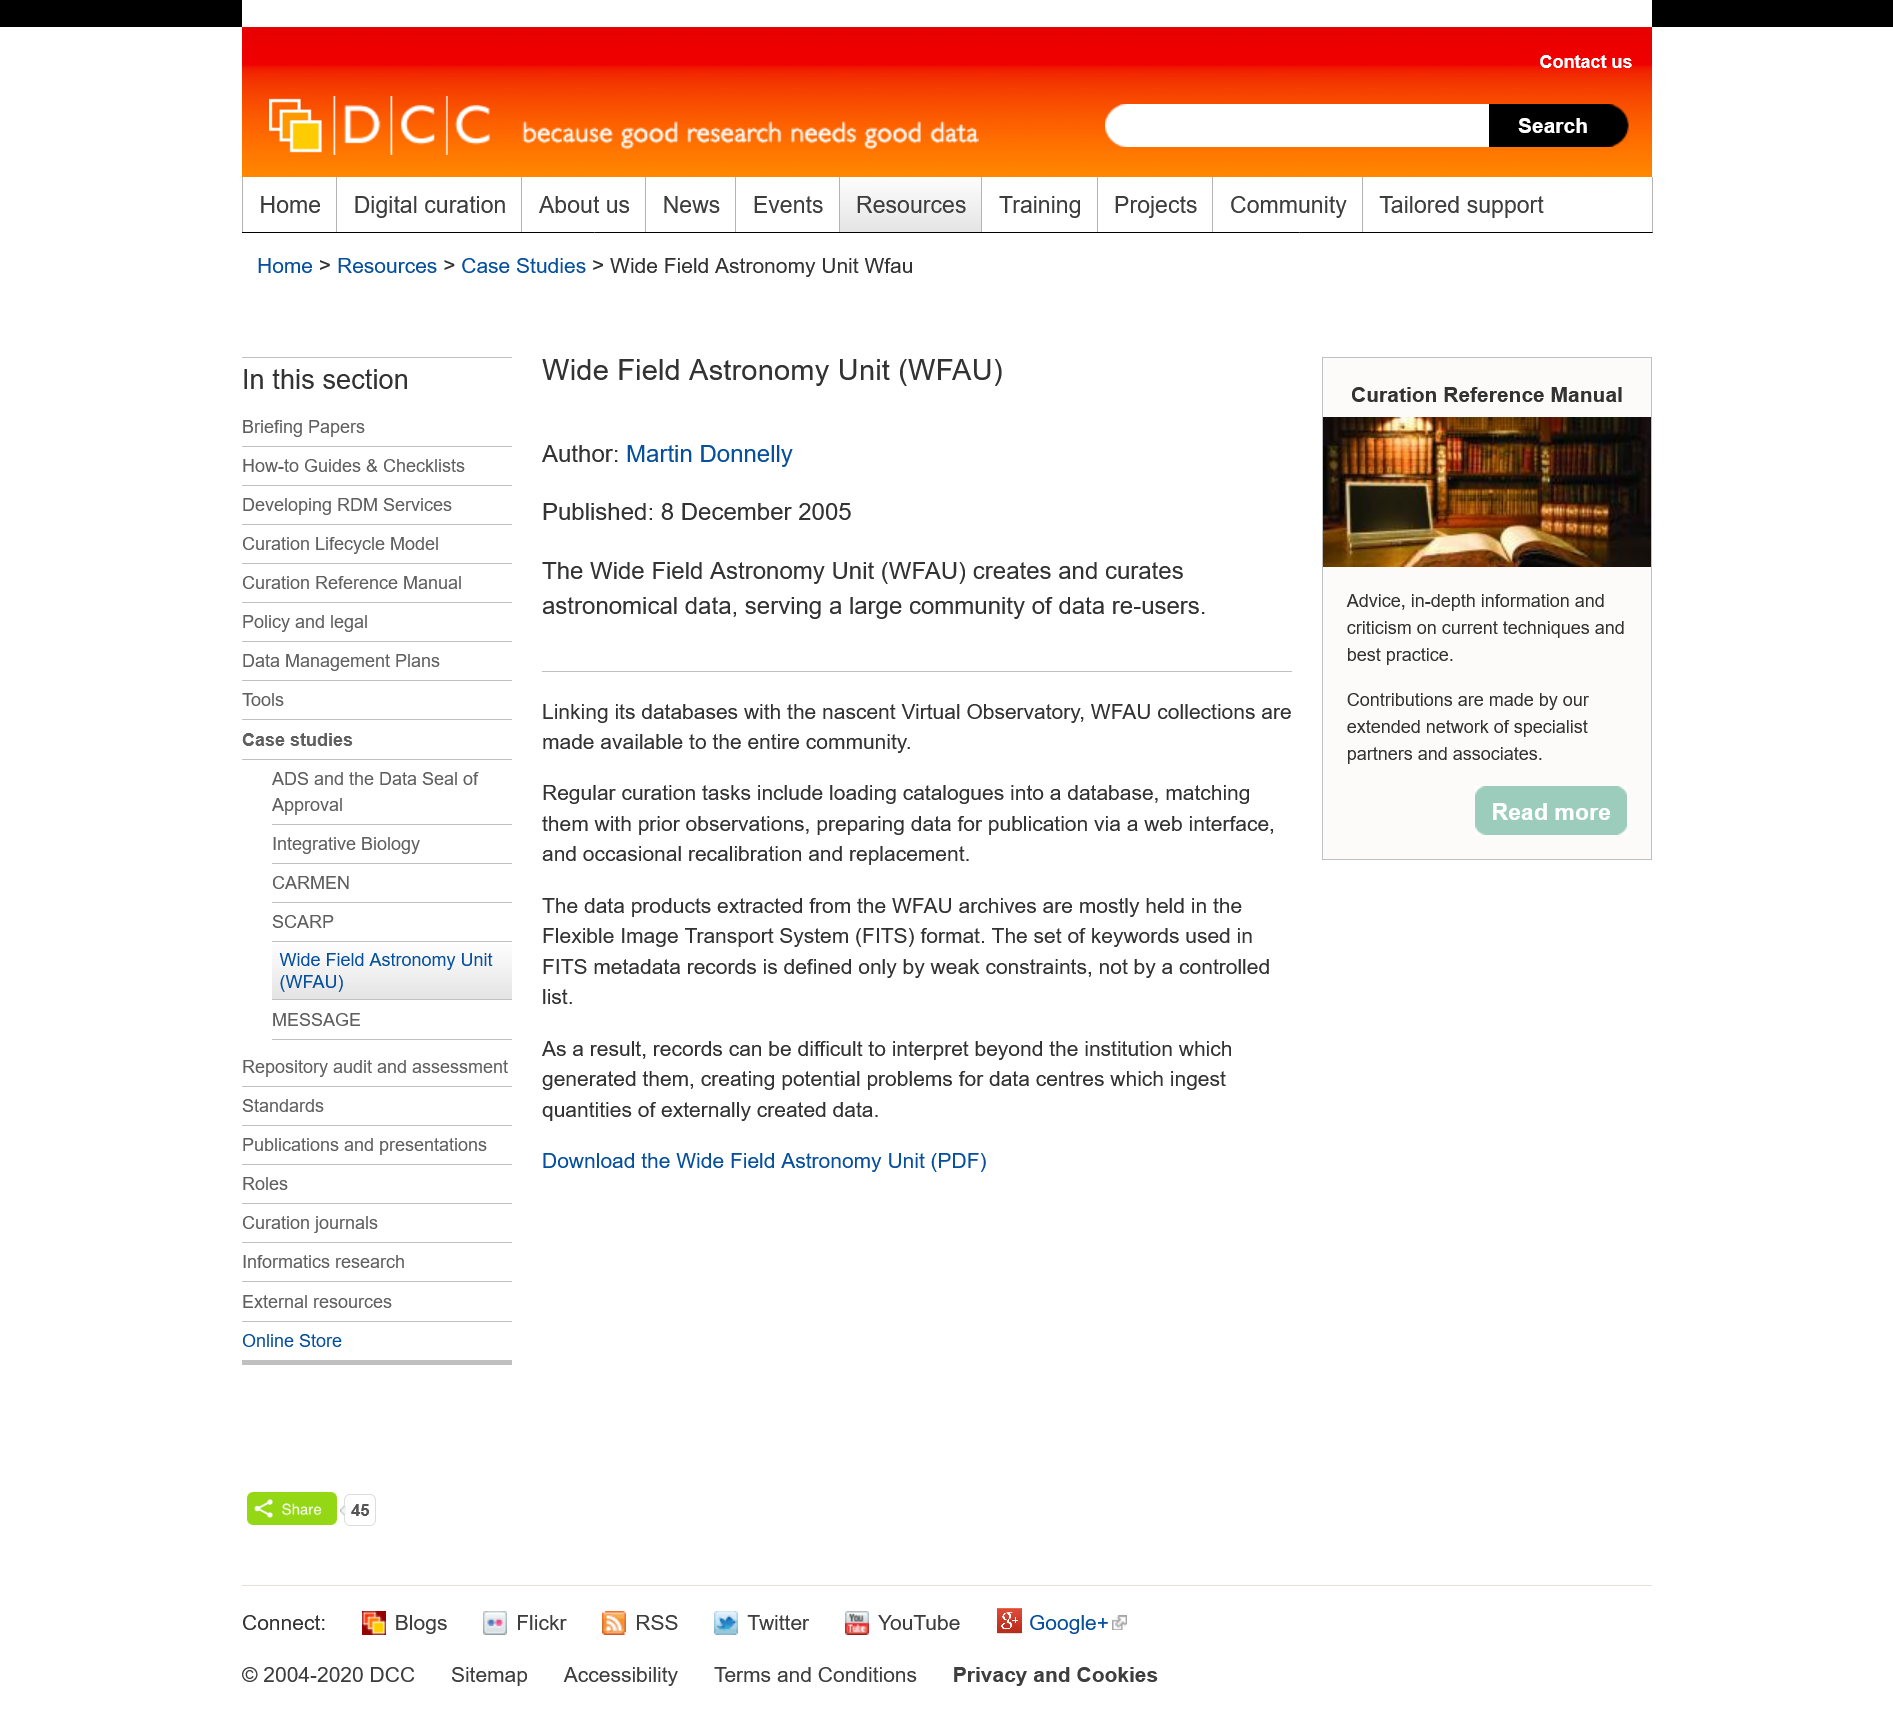Specify some key components in this picture. The Wide Field Astronomy Unit, also known as the WFAU, is a well-known entity in the field of astronomy. The Wide Field Astronomy Unit links its databases with the nascent Virtual Observatory, which is a large-scale collaboration between astronomers and computer scientists to create powerful new tools for exploring astronomical data. The Wide Field Astronomy Unit is responsible for creating and managing astronomical data, providing access to a vast community of data users. 